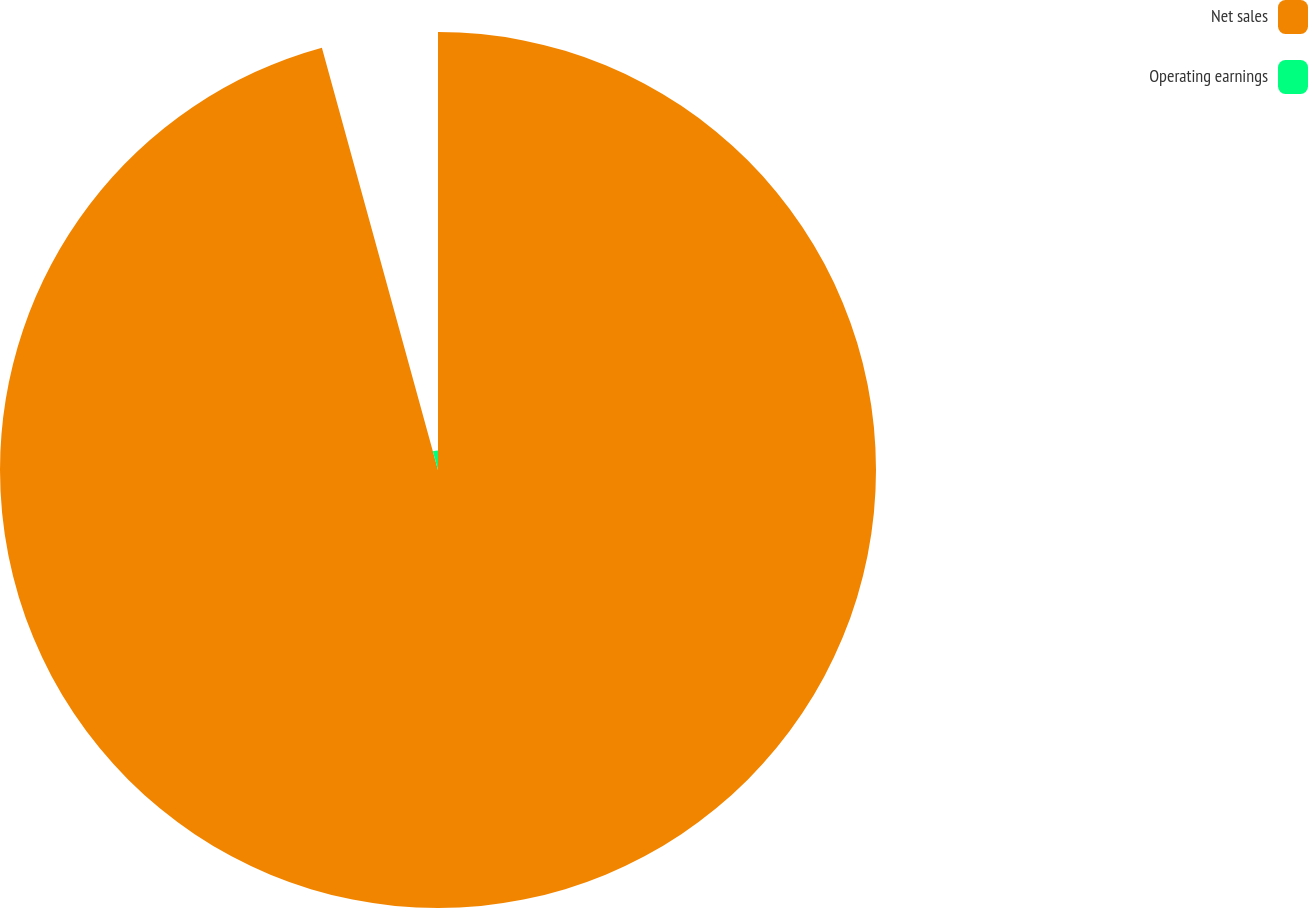Convert chart. <chart><loc_0><loc_0><loc_500><loc_500><pie_chart><fcel>Net sales<fcel>Operating earnings<nl><fcel>95.73%<fcel>4.27%<nl></chart> 